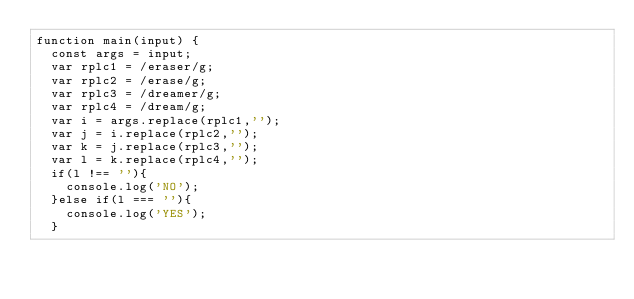<code> <loc_0><loc_0><loc_500><loc_500><_JavaScript_>function main(input) {
  const args = input;
  var rplc1 = /eraser/g;
  var rplc2 = /erase/g;
  var rplc3 = /dreamer/g;
  var rplc4 = /dream/g;
  var i = args.replace(rplc1,'');
  var j = i.replace(rplc2,'');
  var k = j.replace(rplc3,'');
  var l = k.replace(rplc4,'');
  if(l !== ''){
    console.log('NO');
  }else if(l === ''){
    console.log('YES');
  }</code> 